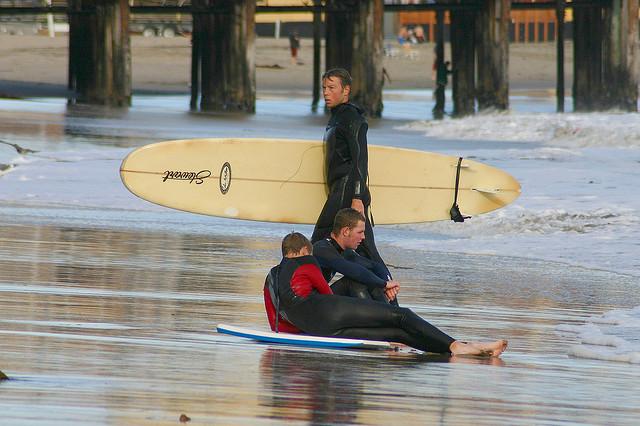Are there any birds in the picture?
Answer briefly. No. How many dudes are here?
Short answer required. 3. How many of these people are standing?
Be succinct. 1. 